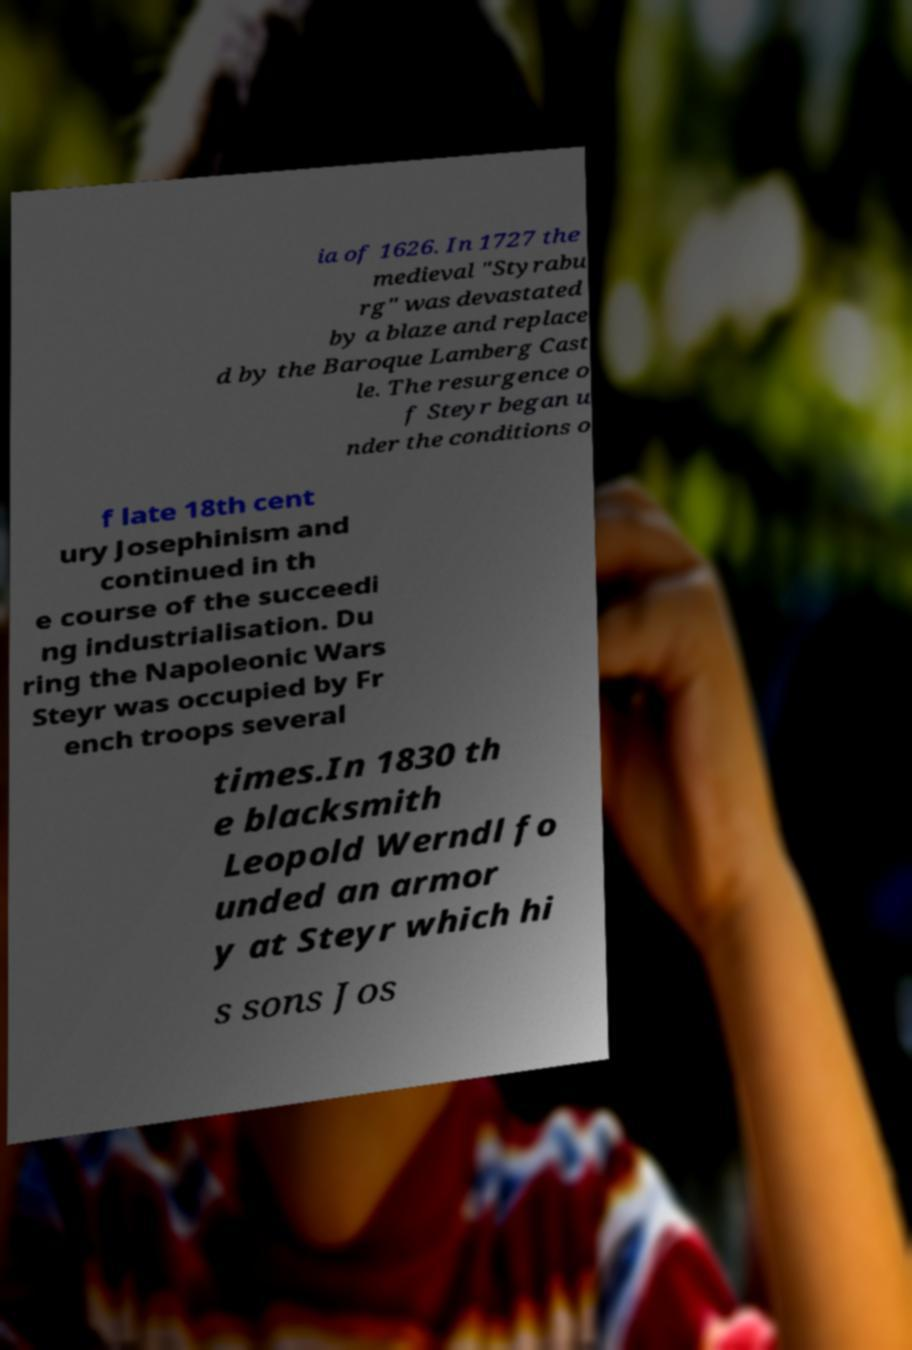For documentation purposes, I need the text within this image transcribed. Could you provide that? ia of 1626. In 1727 the medieval "Styrabu rg" was devastated by a blaze and replace d by the Baroque Lamberg Cast le. The resurgence o f Steyr began u nder the conditions o f late 18th cent ury Josephinism and continued in th e course of the succeedi ng industrialisation. Du ring the Napoleonic Wars Steyr was occupied by Fr ench troops several times.In 1830 th e blacksmith Leopold Werndl fo unded an armor y at Steyr which hi s sons Jos 